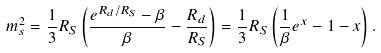<formula> <loc_0><loc_0><loc_500><loc_500>m _ { s } ^ { 2 } = \frac { 1 } { 3 } R _ { S } \left ( \frac { e ^ { R _ { d } / R _ { S } } - \beta } { \beta } - \frac { R _ { d } } { R _ { S } } \right ) = \frac { 1 } { 3 } R _ { S } \left ( \frac { 1 } { \beta } e ^ { x } - 1 - x \right ) .</formula> 